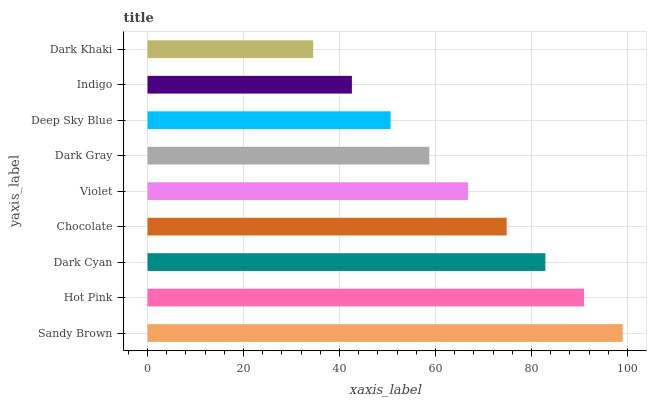Is Dark Khaki the minimum?
Answer yes or no. Yes. Is Sandy Brown the maximum?
Answer yes or no. Yes. Is Hot Pink the minimum?
Answer yes or no. No. Is Hot Pink the maximum?
Answer yes or no. No. Is Sandy Brown greater than Hot Pink?
Answer yes or no. Yes. Is Hot Pink less than Sandy Brown?
Answer yes or no. Yes. Is Hot Pink greater than Sandy Brown?
Answer yes or no. No. Is Sandy Brown less than Hot Pink?
Answer yes or no. No. Is Violet the high median?
Answer yes or no. Yes. Is Violet the low median?
Answer yes or no. Yes. Is Indigo the high median?
Answer yes or no. No. Is Dark Cyan the low median?
Answer yes or no. No. 